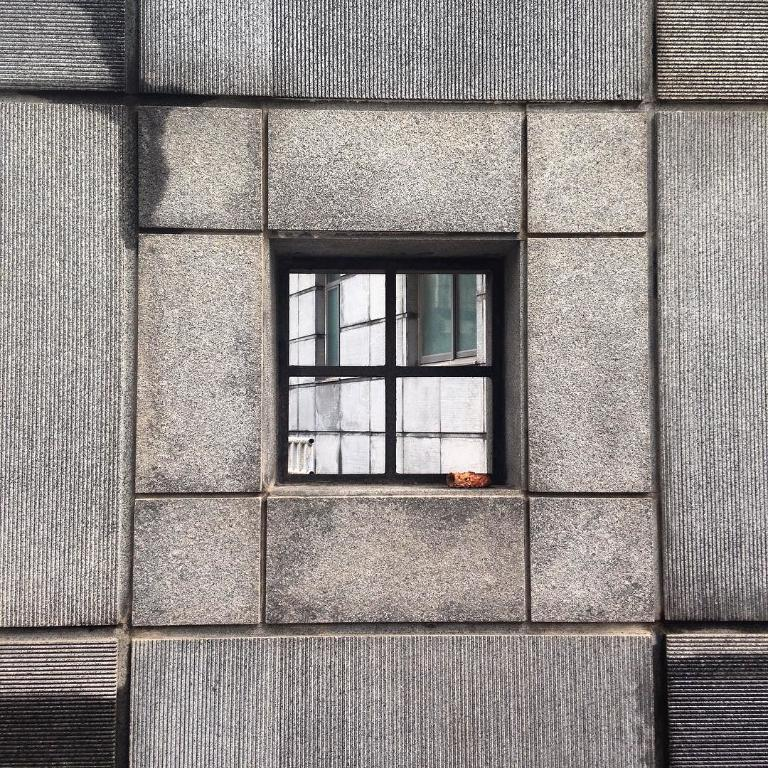What type of structure can be seen in the image? There is a wall with windows in the image. Can you describe the windows on the wall? The windows on the wall are made of glass. What is visible through the glass windows? Another wall with windows is visible through the glass windows. How many bikes are hanging on the wall in the image? There are no bikes present in the image; it only features walls with windows. 